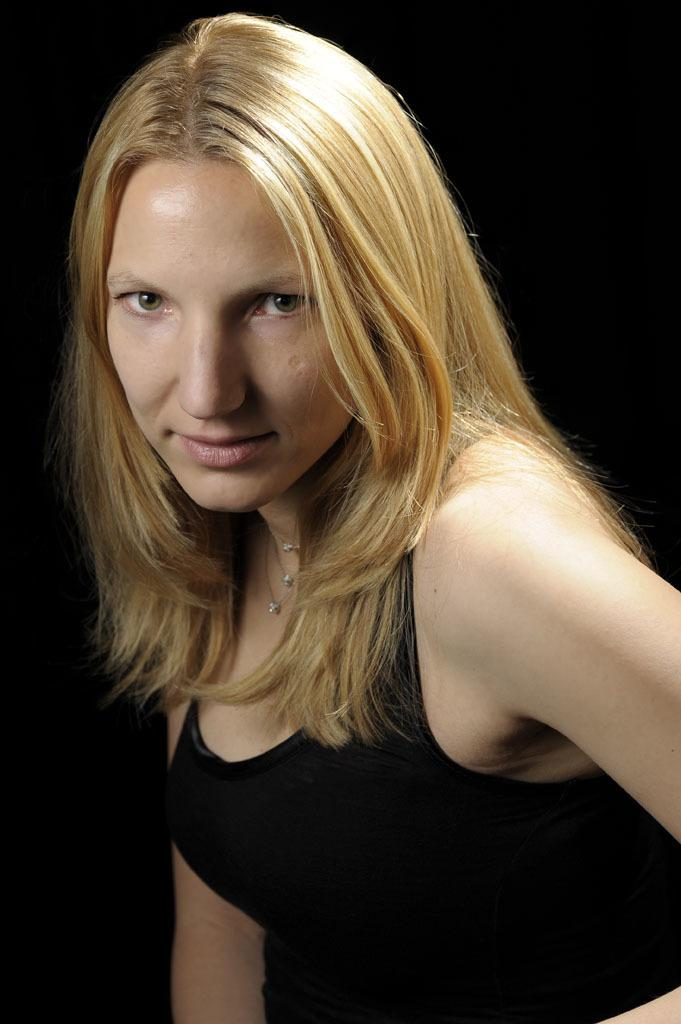Who is present in the image? There is a woman in the image. What is the woman wearing? The woman is wearing a black dress. What type of substance is being used to clean the yard in the image? There is no yard or substance present in the image; it only features a woman wearing a black dress. 